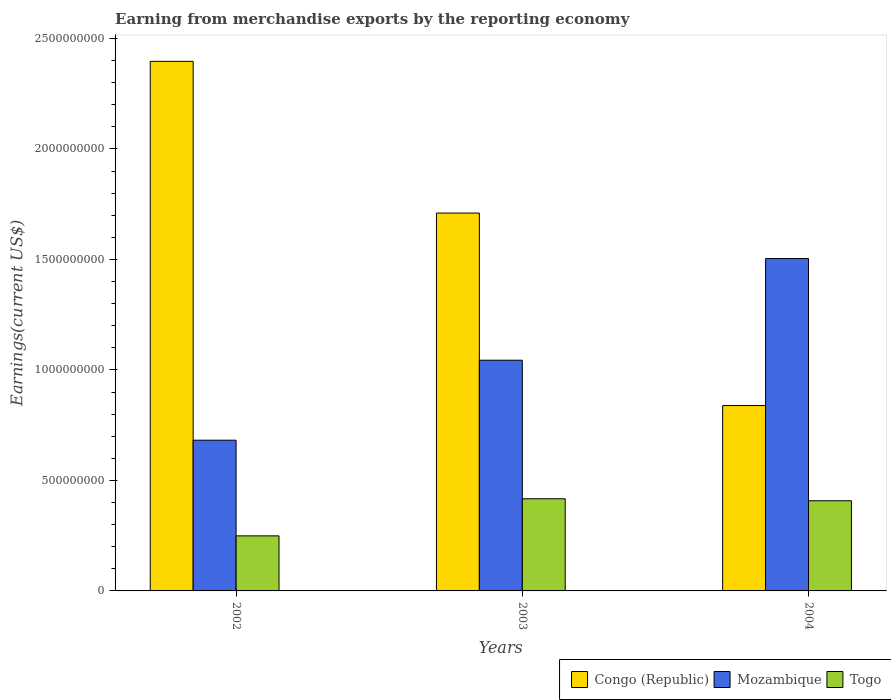How many groups of bars are there?
Offer a very short reply. 3. How many bars are there on the 1st tick from the right?
Ensure brevity in your answer.  3. What is the amount earned from merchandise exports in Mozambique in 2002?
Provide a succinct answer. 6.82e+08. Across all years, what is the maximum amount earned from merchandise exports in Congo (Republic)?
Provide a short and direct response. 2.40e+09. Across all years, what is the minimum amount earned from merchandise exports in Mozambique?
Your answer should be very brief. 6.82e+08. In which year was the amount earned from merchandise exports in Mozambique maximum?
Your response must be concise. 2004. In which year was the amount earned from merchandise exports in Mozambique minimum?
Ensure brevity in your answer.  2002. What is the total amount earned from merchandise exports in Mozambique in the graph?
Offer a terse response. 3.23e+09. What is the difference between the amount earned from merchandise exports in Togo in 2002 and that in 2004?
Your response must be concise. -1.59e+08. What is the difference between the amount earned from merchandise exports in Togo in 2003 and the amount earned from merchandise exports in Mozambique in 2004?
Your response must be concise. -1.09e+09. What is the average amount earned from merchandise exports in Mozambique per year?
Provide a short and direct response. 1.08e+09. In the year 2004, what is the difference between the amount earned from merchandise exports in Togo and amount earned from merchandise exports in Congo (Republic)?
Make the answer very short. -4.31e+08. What is the ratio of the amount earned from merchandise exports in Togo in 2002 to that in 2003?
Provide a succinct answer. 0.6. Is the amount earned from merchandise exports in Togo in 2003 less than that in 2004?
Offer a terse response. No. Is the difference between the amount earned from merchandise exports in Togo in 2003 and 2004 greater than the difference between the amount earned from merchandise exports in Congo (Republic) in 2003 and 2004?
Make the answer very short. No. What is the difference between the highest and the second highest amount earned from merchandise exports in Congo (Republic)?
Your answer should be compact. 6.86e+08. What is the difference between the highest and the lowest amount earned from merchandise exports in Mozambique?
Offer a terse response. 8.22e+08. In how many years, is the amount earned from merchandise exports in Togo greater than the average amount earned from merchandise exports in Togo taken over all years?
Provide a succinct answer. 2. Is the sum of the amount earned from merchandise exports in Mozambique in 2002 and 2004 greater than the maximum amount earned from merchandise exports in Congo (Republic) across all years?
Give a very brief answer. No. What does the 1st bar from the left in 2002 represents?
Give a very brief answer. Congo (Republic). What does the 2nd bar from the right in 2004 represents?
Give a very brief answer. Mozambique. What is the difference between two consecutive major ticks on the Y-axis?
Your response must be concise. 5.00e+08. Are the values on the major ticks of Y-axis written in scientific E-notation?
Keep it short and to the point. No. Does the graph contain any zero values?
Offer a terse response. No. What is the title of the graph?
Your answer should be very brief. Earning from merchandise exports by the reporting economy. Does "South Asia" appear as one of the legend labels in the graph?
Provide a short and direct response. No. What is the label or title of the Y-axis?
Your answer should be very brief. Earnings(current US$). What is the Earnings(current US$) in Congo (Republic) in 2002?
Offer a very short reply. 2.40e+09. What is the Earnings(current US$) of Mozambique in 2002?
Offer a very short reply. 6.82e+08. What is the Earnings(current US$) of Togo in 2002?
Provide a succinct answer. 2.49e+08. What is the Earnings(current US$) in Congo (Republic) in 2003?
Make the answer very short. 1.71e+09. What is the Earnings(current US$) in Mozambique in 2003?
Offer a very short reply. 1.04e+09. What is the Earnings(current US$) in Togo in 2003?
Give a very brief answer. 4.17e+08. What is the Earnings(current US$) in Congo (Republic) in 2004?
Offer a very short reply. 8.39e+08. What is the Earnings(current US$) of Mozambique in 2004?
Your response must be concise. 1.50e+09. What is the Earnings(current US$) in Togo in 2004?
Offer a terse response. 4.08e+08. Across all years, what is the maximum Earnings(current US$) in Congo (Republic)?
Your answer should be compact. 2.40e+09. Across all years, what is the maximum Earnings(current US$) in Mozambique?
Offer a terse response. 1.50e+09. Across all years, what is the maximum Earnings(current US$) of Togo?
Make the answer very short. 4.17e+08. Across all years, what is the minimum Earnings(current US$) in Congo (Republic)?
Provide a succinct answer. 8.39e+08. Across all years, what is the minimum Earnings(current US$) of Mozambique?
Your answer should be compact. 6.82e+08. Across all years, what is the minimum Earnings(current US$) of Togo?
Provide a short and direct response. 2.49e+08. What is the total Earnings(current US$) in Congo (Republic) in the graph?
Ensure brevity in your answer.  4.94e+09. What is the total Earnings(current US$) in Mozambique in the graph?
Make the answer very short. 3.23e+09. What is the total Earnings(current US$) in Togo in the graph?
Your response must be concise. 1.07e+09. What is the difference between the Earnings(current US$) of Congo (Republic) in 2002 and that in 2003?
Offer a very short reply. 6.86e+08. What is the difference between the Earnings(current US$) in Mozambique in 2002 and that in 2003?
Your answer should be compact. -3.62e+08. What is the difference between the Earnings(current US$) of Togo in 2002 and that in 2003?
Give a very brief answer. -1.68e+08. What is the difference between the Earnings(current US$) in Congo (Republic) in 2002 and that in 2004?
Make the answer very short. 1.56e+09. What is the difference between the Earnings(current US$) of Mozambique in 2002 and that in 2004?
Provide a short and direct response. -8.22e+08. What is the difference between the Earnings(current US$) of Togo in 2002 and that in 2004?
Provide a short and direct response. -1.59e+08. What is the difference between the Earnings(current US$) in Congo (Republic) in 2003 and that in 2004?
Offer a very short reply. 8.71e+08. What is the difference between the Earnings(current US$) in Mozambique in 2003 and that in 2004?
Ensure brevity in your answer.  -4.60e+08. What is the difference between the Earnings(current US$) in Togo in 2003 and that in 2004?
Offer a very short reply. 9.05e+06. What is the difference between the Earnings(current US$) in Congo (Republic) in 2002 and the Earnings(current US$) in Mozambique in 2003?
Provide a short and direct response. 1.35e+09. What is the difference between the Earnings(current US$) of Congo (Republic) in 2002 and the Earnings(current US$) of Togo in 2003?
Keep it short and to the point. 1.98e+09. What is the difference between the Earnings(current US$) of Mozambique in 2002 and the Earnings(current US$) of Togo in 2003?
Offer a very short reply. 2.65e+08. What is the difference between the Earnings(current US$) in Congo (Republic) in 2002 and the Earnings(current US$) in Mozambique in 2004?
Ensure brevity in your answer.  8.92e+08. What is the difference between the Earnings(current US$) in Congo (Republic) in 2002 and the Earnings(current US$) in Togo in 2004?
Provide a short and direct response. 1.99e+09. What is the difference between the Earnings(current US$) of Mozambique in 2002 and the Earnings(current US$) of Togo in 2004?
Your response must be concise. 2.74e+08. What is the difference between the Earnings(current US$) in Congo (Republic) in 2003 and the Earnings(current US$) in Mozambique in 2004?
Your answer should be compact. 2.06e+08. What is the difference between the Earnings(current US$) of Congo (Republic) in 2003 and the Earnings(current US$) of Togo in 2004?
Keep it short and to the point. 1.30e+09. What is the difference between the Earnings(current US$) of Mozambique in 2003 and the Earnings(current US$) of Togo in 2004?
Give a very brief answer. 6.36e+08. What is the average Earnings(current US$) in Congo (Republic) per year?
Keep it short and to the point. 1.65e+09. What is the average Earnings(current US$) in Mozambique per year?
Give a very brief answer. 1.08e+09. What is the average Earnings(current US$) of Togo per year?
Offer a terse response. 3.58e+08. In the year 2002, what is the difference between the Earnings(current US$) in Congo (Republic) and Earnings(current US$) in Mozambique?
Offer a terse response. 1.71e+09. In the year 2002, what is the difference between the Earnings(current US$) of Congo (Republic) and Earnings(current US$) of Togo?
Your answer should be very brief. 2.15e+09. In the year 2002, what is the difference between the Earnings(current US$) of Mozambique and Earnings(current US$) of Togo?
Your answer should be compact. 4.33e+08. In the year 2003, what is the difference between the Earnings(current US$) in Congo (Republic) and Earnings(current US$) in Mozambique?
Your answer should be very brief. 6.66e+08. In the year 2003, what is the difference between the Earnings(current US$) in Congo (Republic) and Earnings(current US$) in Togo?
Provide a short and direct response. 1.29e+09. In the year 2003, what is the difference between the Earnings(current US$) of Mozambique and Earnings(current US$) of Togo?
Your answer should be very brief. 6.27e+08. In the year 2004, what is the difference between the Earnings(current US$) in Congo (Republic) and Earnings(current US$) in Mozambique?
Your response must be concise. -6.65e+08. In the year 2004, what is the difference between the Earnings(current US$) of Congo (Republic) and Earnings(current US$) of Togo?
Offer a terse response. 4.31e+08. In the year 2004, what is the difference between the Earnings(current US$) of Mozambique and Earnings(current US$) of Togo?
Keep it short and to the point. 1.10e+09. What is the ratio of the Earnings(current US$) in Congo (Republic) in 2002 to that in 2003?
Your answer should be very brief. 1.4. What is the ratio of the Earnings(current US$) in Mozambique in 2002 to that in 2003?
Your answer should be very brief. 0.65. What is the ratio of the Earnings(current US$) in Togo in 2002 to that in 2003?
Provide a short and direct response. 0.6. What is the ratio of the Earnings(current US$) of Congo (Republic) in 2002 to that in 2004?
Provide a succinct answer. 2.86. What is the ratio of the Earnings(current US$) of Mozambique in 2002 to that in 2004?
Provide a short and direct response. 0.45. What is the ratio of the Earnings(current US$) of Togo in 2002 to that in 2004?
Keep it short and to the point. 0.61. What is the ratio of the Earnings(current US$) of Congo (Republic) in 2003 to that in 2004?
Your answer should be very brief. 2.04. What is the ratio of the Earnings(current US$) in Mozambique in 2003 to that in 2004?
Make the answer very short. 0.69. What is the ratio of the Earnings(current US$) of Togo in 2003 to that in 2004?
Keep it short and to the point. 1.02. What is the difference between the highest and the second highest Earnings(current US$) in Congo (Republic)?
Provide a short and direct response. 6.86e+08. What is the difference between the highest and the second highest Earnings(current US$) in Mozambique?
Your answer should be compact. 4.60e+08. What is the difference between the highest and the second highest Earnings(current US$) of Togo?
Your answer should be compact. 9.05e+06. What is the difference between the highest and the lowest Earnings(current US$) of Congo (Republic)?
Offer a very short reply. 1.56e+09. What is the difference between the highest and the lowest Earnings(current US$) of Mozambique?
Your response must be concise. 8.22e+08. What is the difference between the highest and the lowest Earnings(current US$) of Togo?
Offer a very short reply. 1.68e+08. 